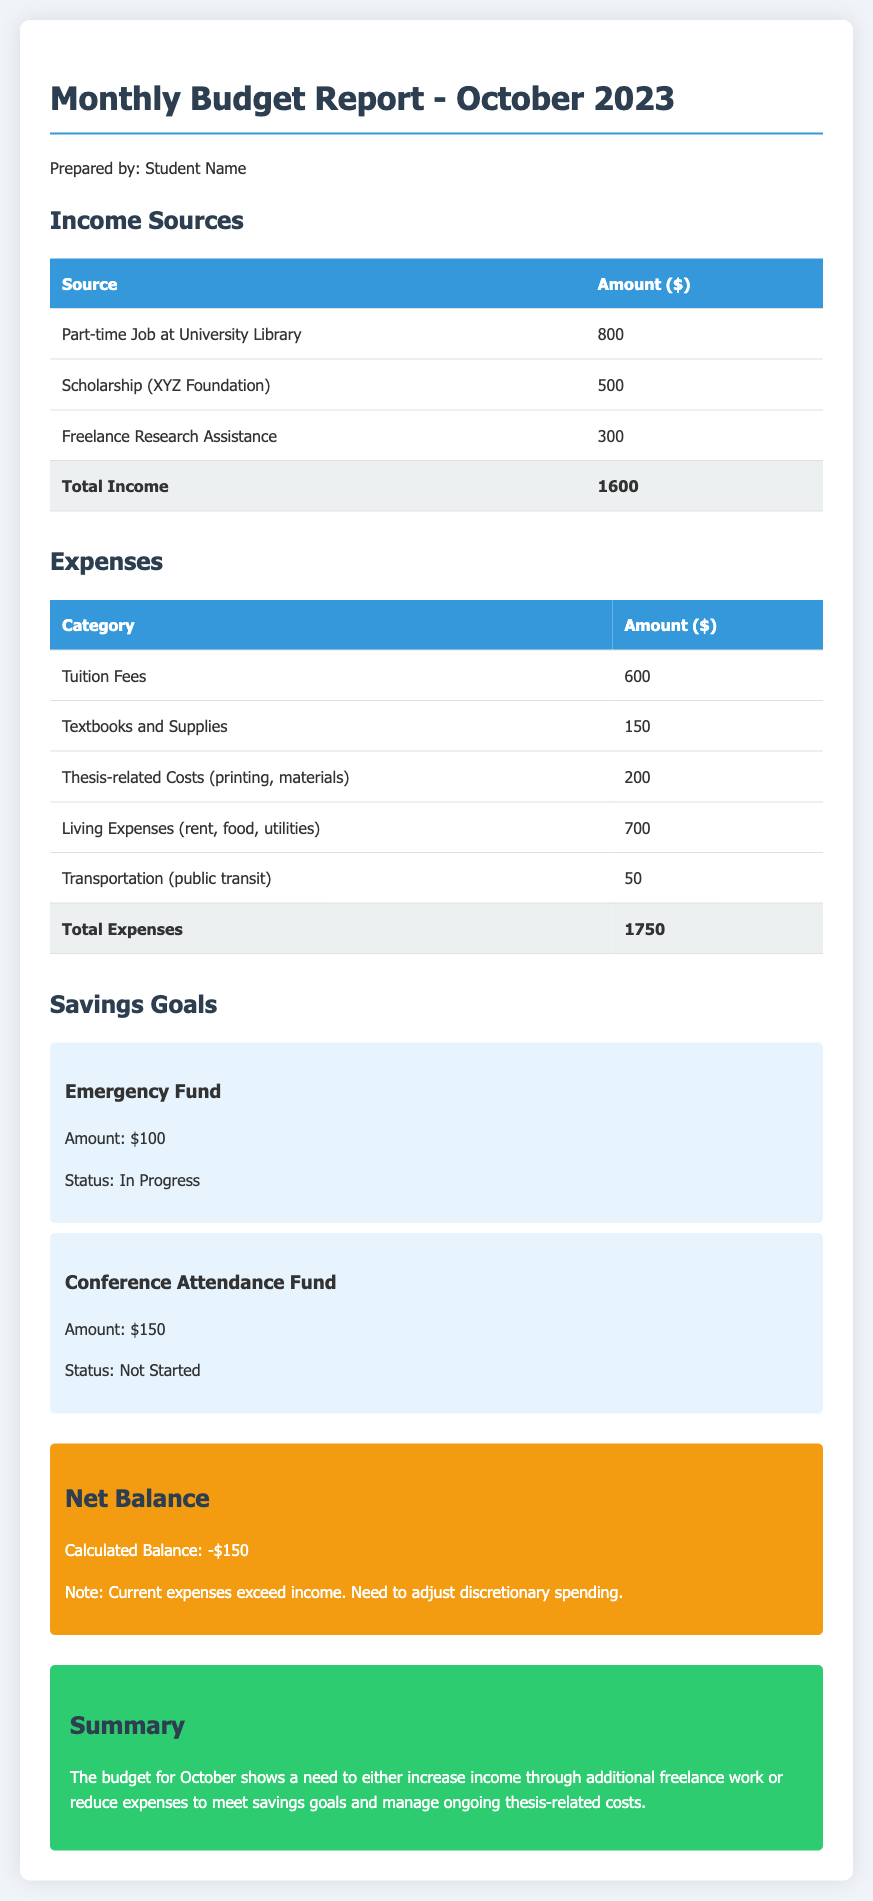What is the total income? The total income is the sum of all income sources listed in the document, which is 800 + 500 + 300 = 1600.
Answer: 1600 What is the amount allocated for thesis-related costs? The document specifies that the amount allocated for thesis-related costs (printing, materials) is 200.
Answer: 200 What is the total amount of expenses? The total expenses are calculated by summing all expense categories, which is 600 + 150 + 200 + 700 + 50 = 1750.
Answer: 1750 What is the status of the Emergency Fund savings goal? The document indicates that the status of the Emergency Fund is "In Progress".
Answer: In Progress What is the calculated net balance? The calculated net balance is presented as the difference between total income and total expenses, resulting in a balance of -150.
Answer: -150 Which income source provides the highest amount? The income source that provides the highest amount listed in the report is the "Part-time Job at University Library".
Answer: Part-time Job at University Library Which category has the highest expense? The highest expense category in the document is "Living Expenses (rent, food, utilities)".
Answer: Living Expenses (rent, food, utilities) What is the amount set for the Conference Attendance Fund? The Conference Attendance Fund is allocated an amount of 150 as stated in the savings goal section.
Answer: 150 What does the summary suggest about the budget situation? The summary indicates a need to either increase income or reduce expenses due to the current budget situation.
Answer: Increase income or reduce expenses 